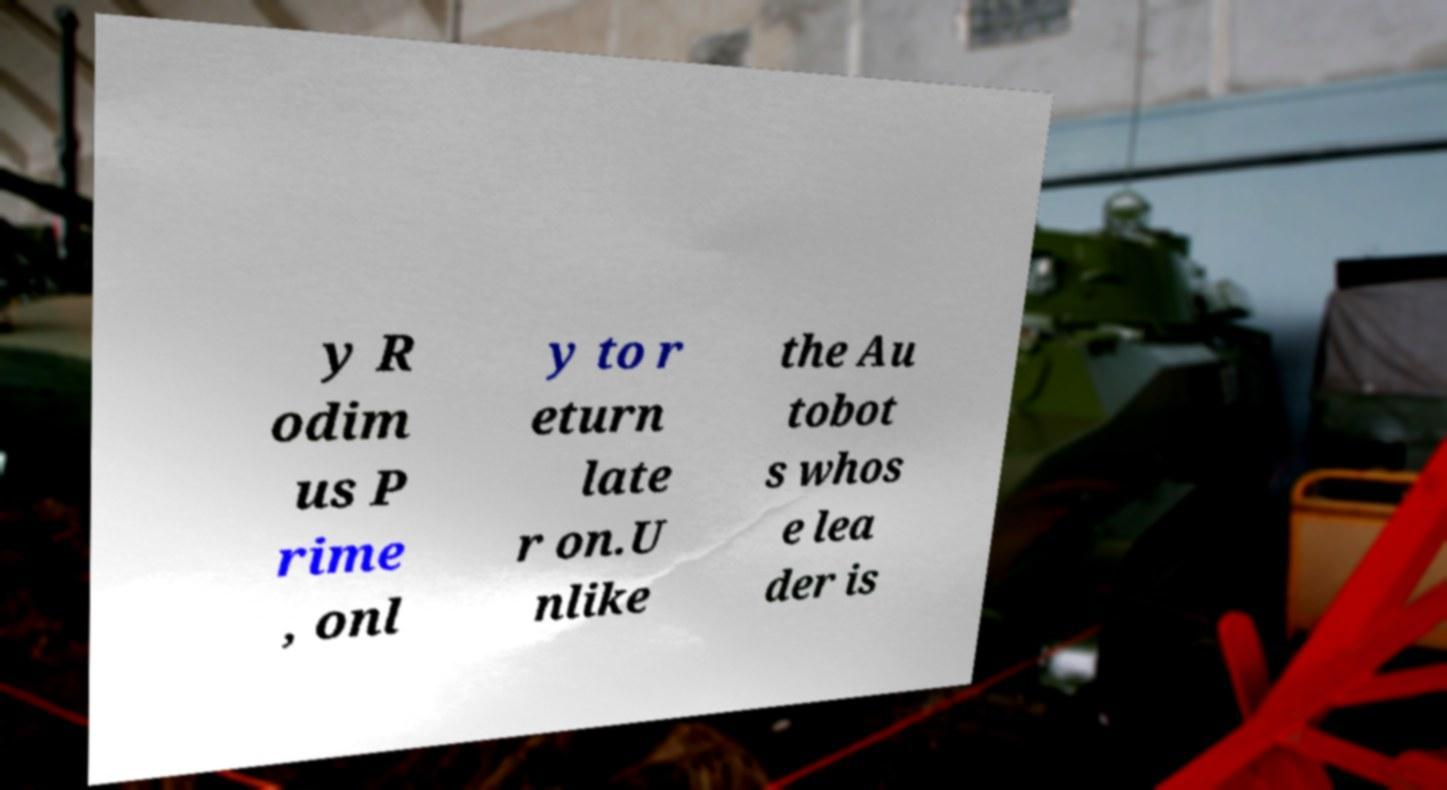Can you accurately transcribe the text from the provided image for me? y R odim us P rime , onl y to r eturn late r on.U nlike the Au tobot s whos e lea der is 